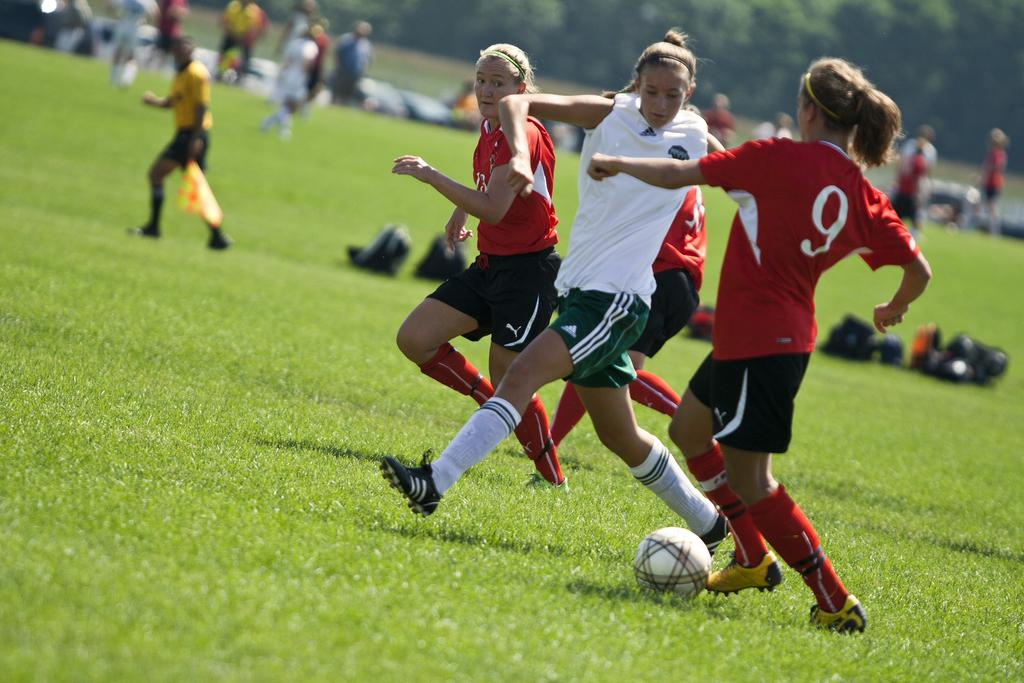<image>
Share a concise interpretation of the image provided. Player number 9 has the ball, but someone on the opposing team is trying to get it. 